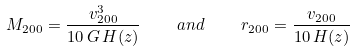Convert formula to latex. <formula><loc_0><loc_0><loc_500><loc_500>M _ { 2 0 0 } = \frac { v ^ { 3 } _ { 2 0 0 } } { 1 0 \, G \, H ( z ) } \quad a n d \quad r _ { 2 0 0 } = \frac { v _ { 2 0 0 } } { 1 0 \, H ( z ) }</formula> 